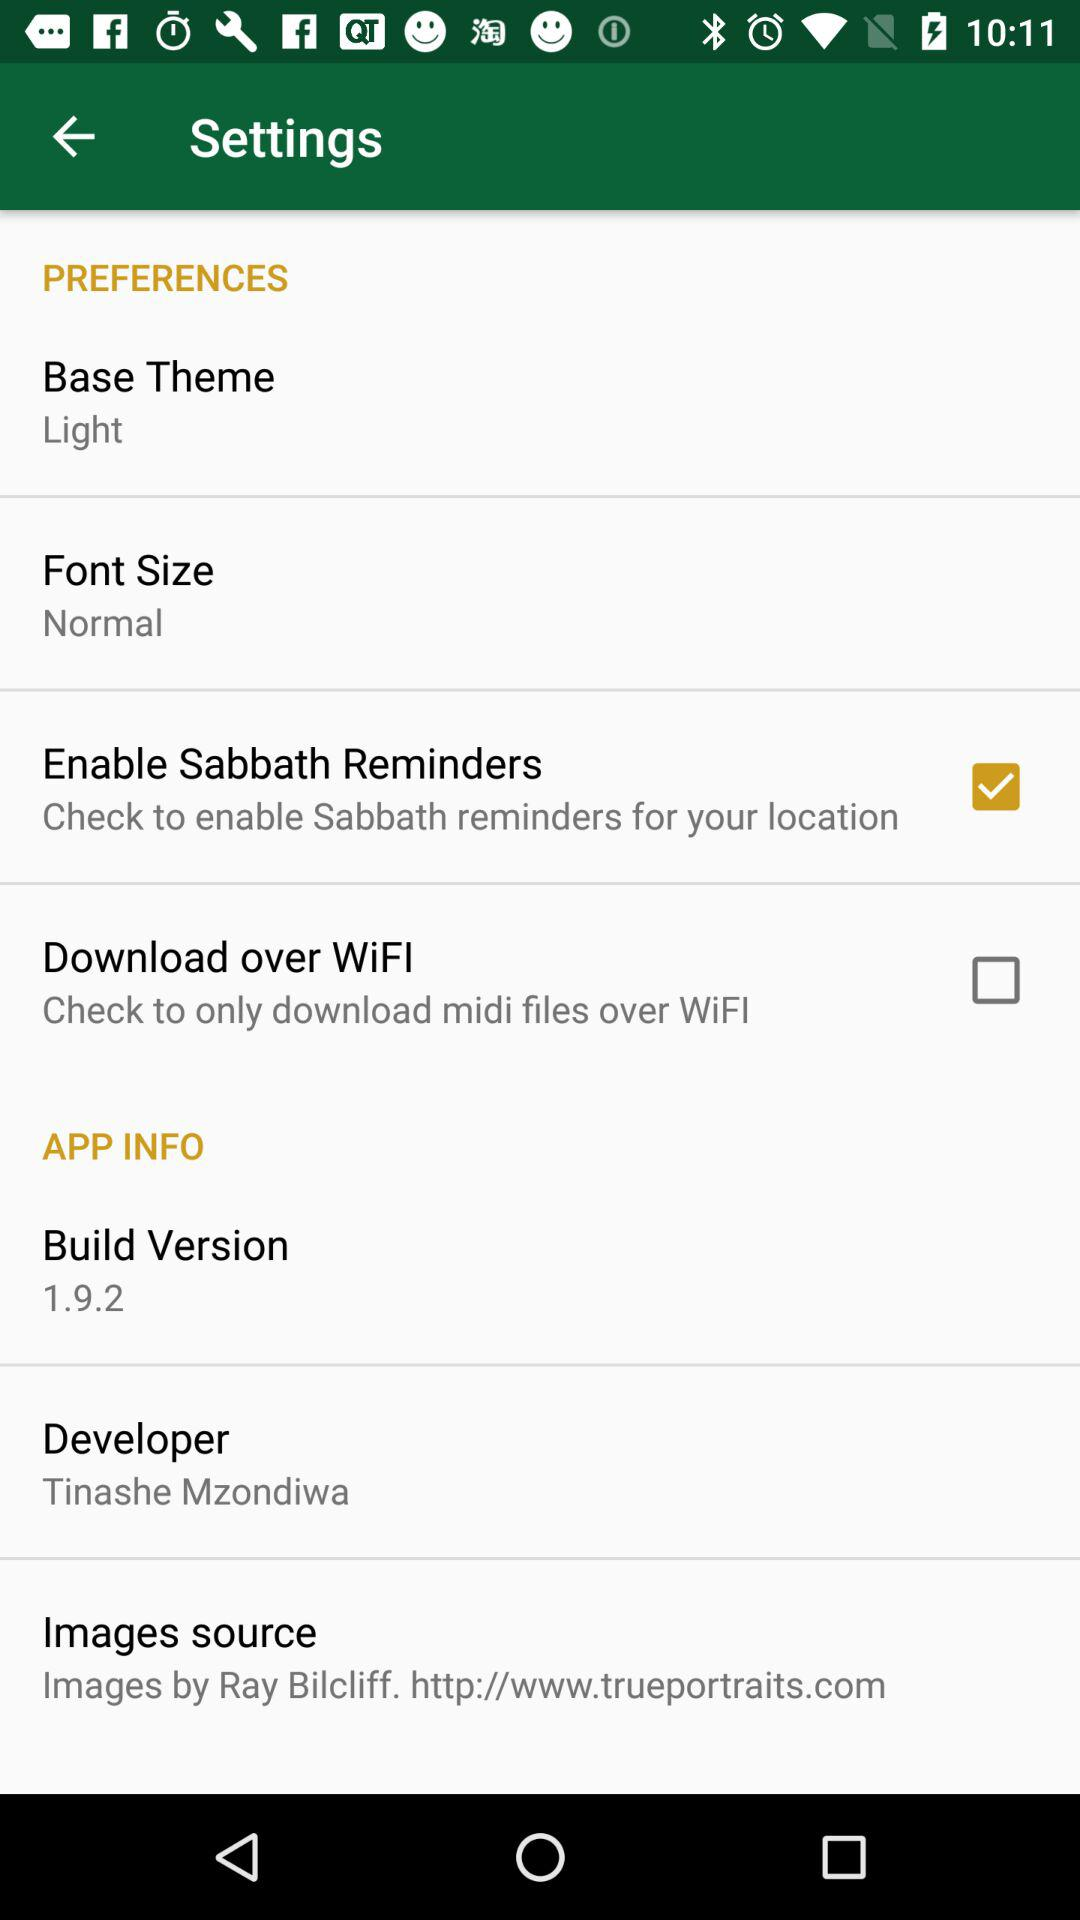What is the version? The version is 1.9.2. 